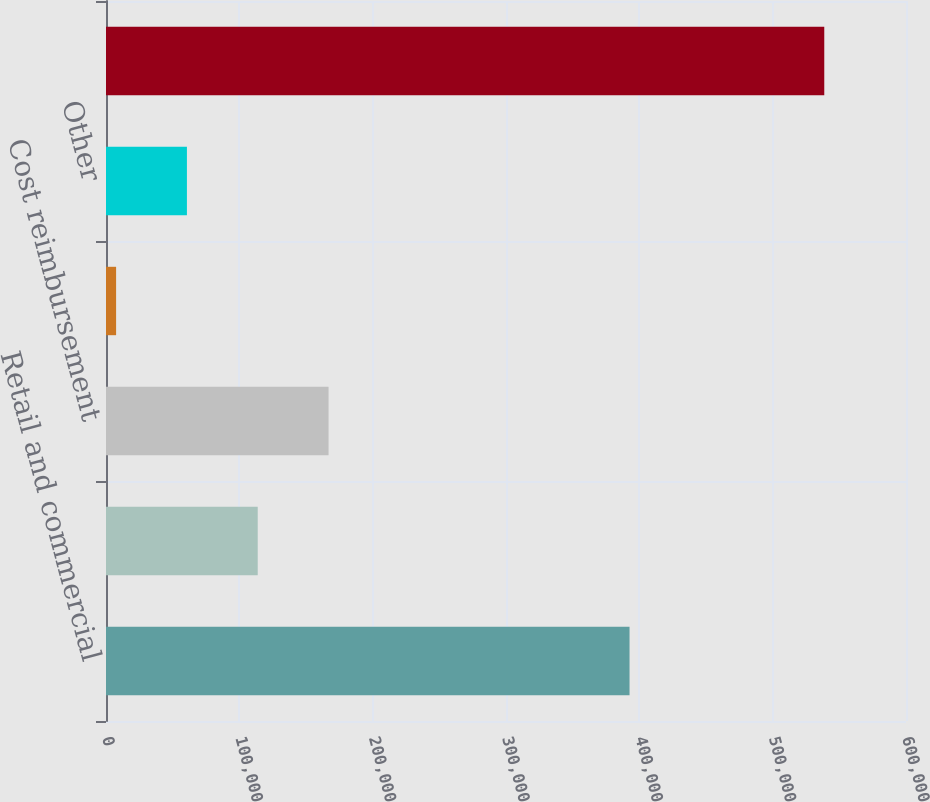Convert chart to OTSL. <chart><loc_0><loc_0><loc_500><loc_500><bar_chart><fcel>Retail and commercial<fcel>Residential (1)<fcel>Cost reimbursement<fcel>Percentage rent<fcel>Other<fcel>Total rental income<nl><fcel>392657<fcel>113801<fcel>166914<fcel>7576<fcel>60688.5<fcel>538701<nl></chart> 